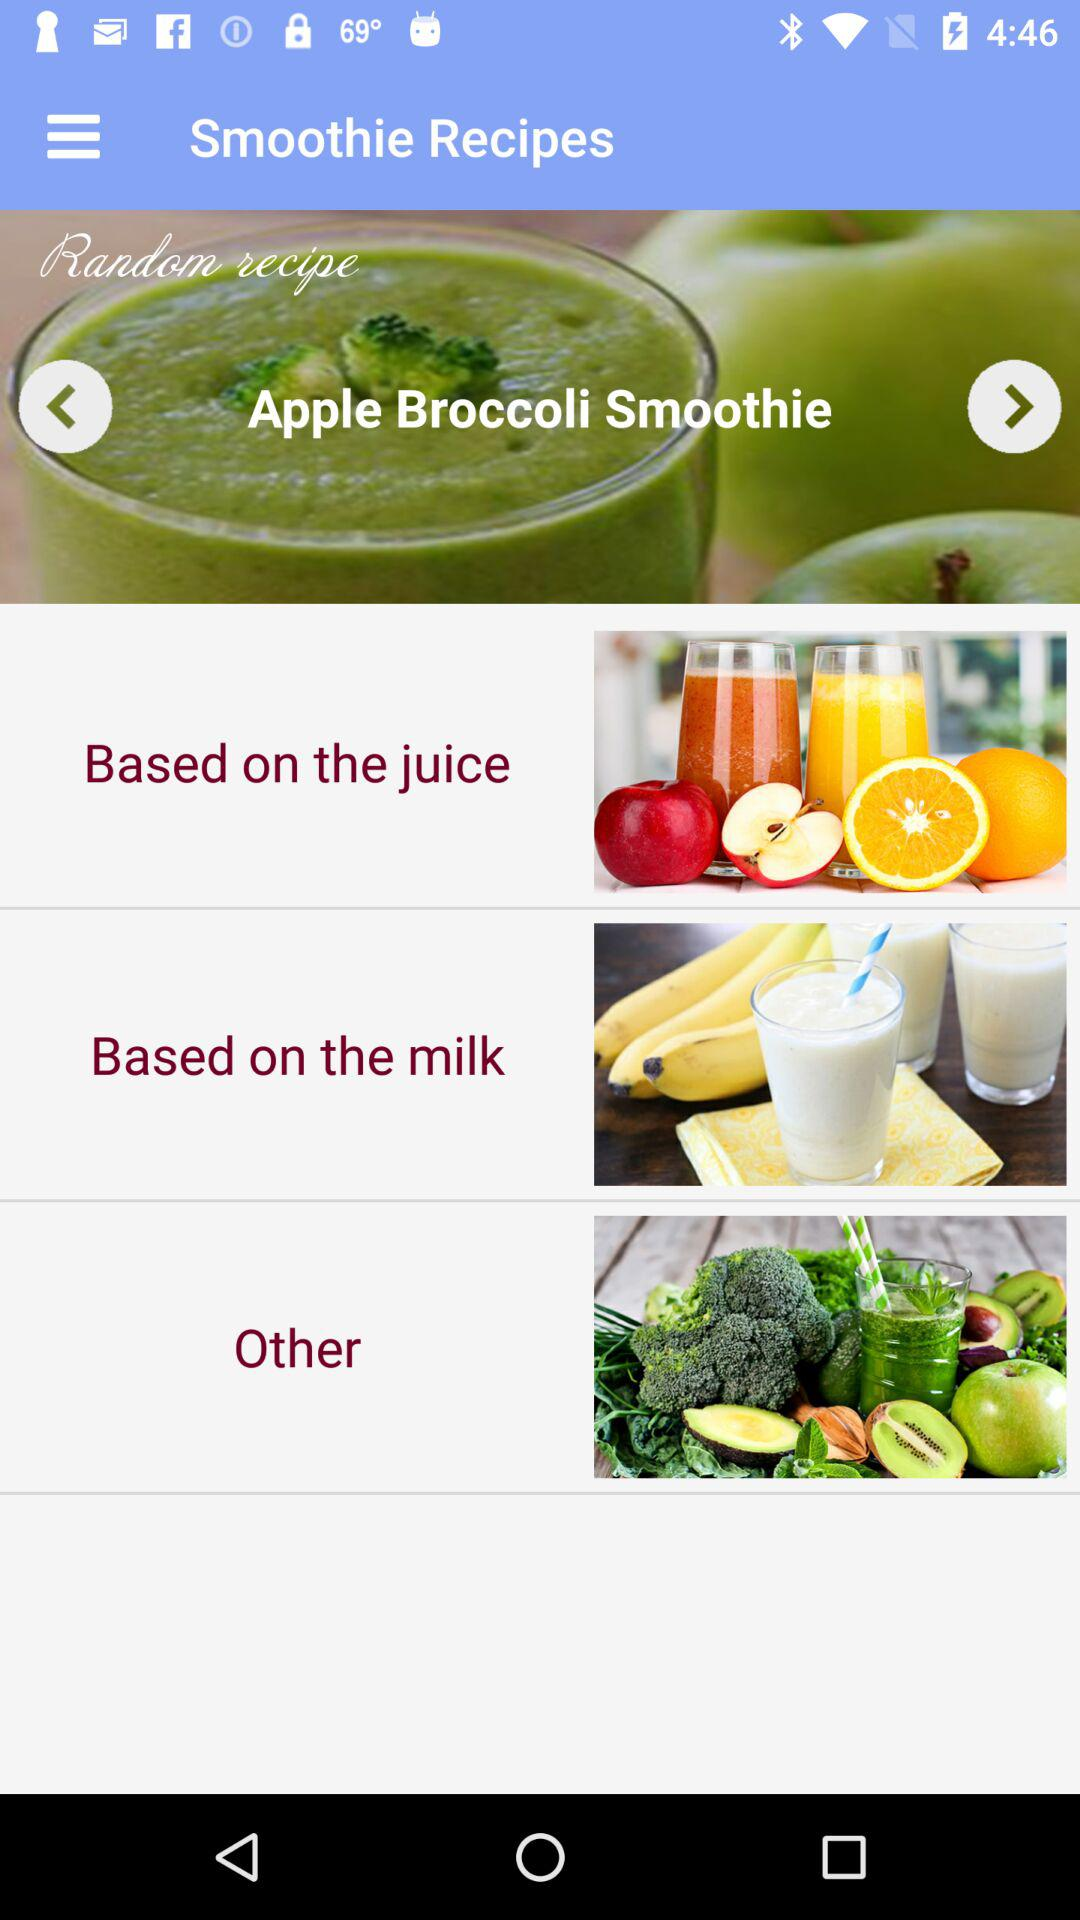What is the name of the recipe shown for the smoothie? The name of the recipe is "Apple Broccoli Smoothie". 